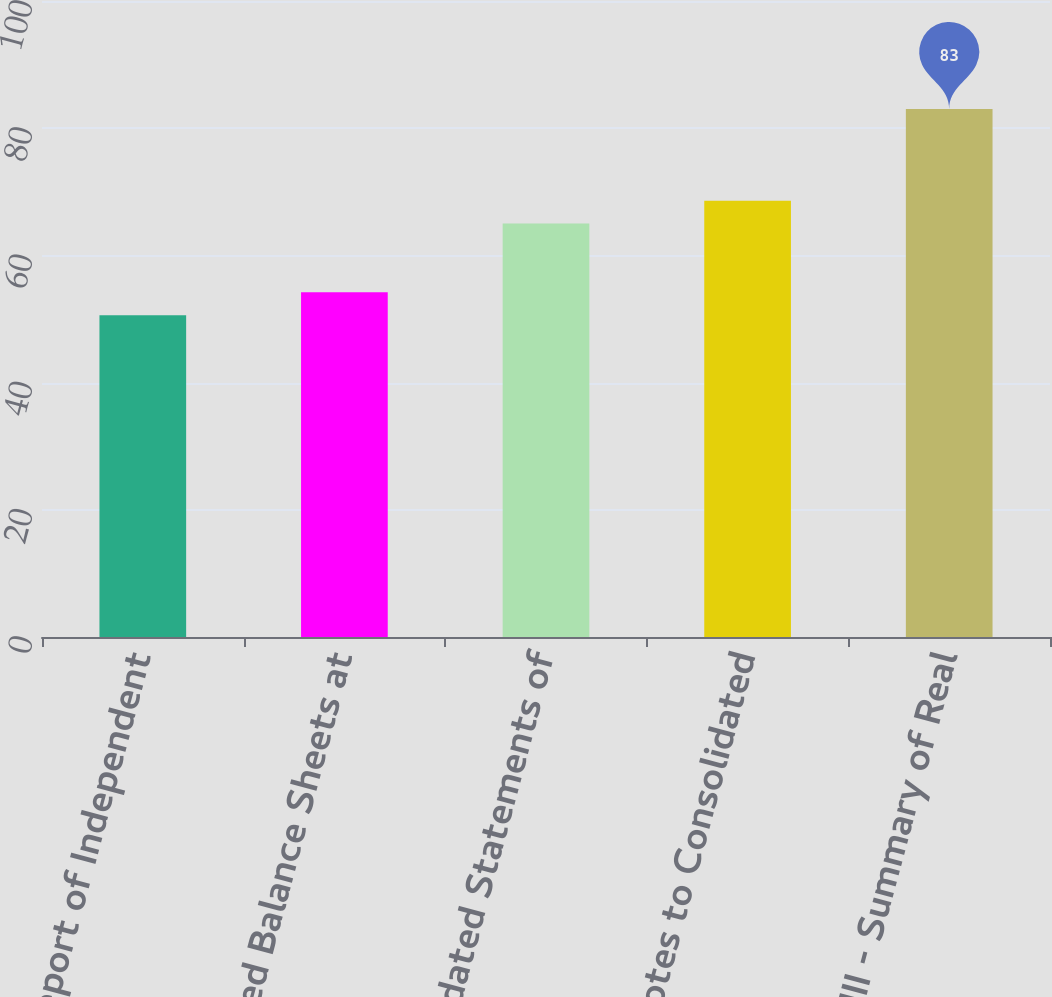<chart> <loc_0><loc_0><loc_500><loc_500><bar_chart><fcel>Report of Independent<fcel>Consolidated Balance Sheets at<fcel>Consolidated Statements of<fcel>Notes to Consolidated<fcel>Schedule III - Summary of Real<nl><fcel>50.6<fcel>54.2<fcel>65<fcel>68.6<fcel>83<nl></chart> 